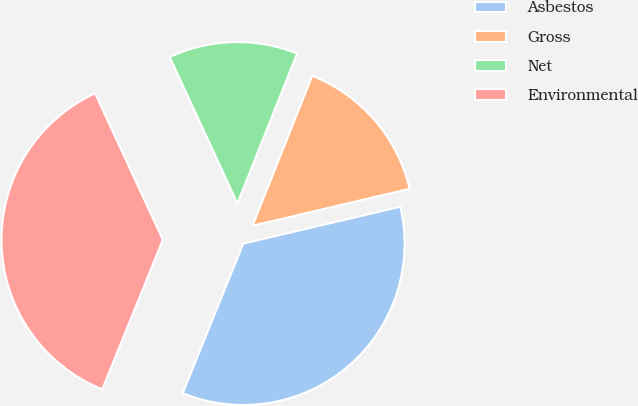Convert chart to OTSL. <chart><loc_0><loc_0><loc_500><loc_500><pie_chart><fcel>Asbestos<fcel>Gross<fcel>Net<fcel>Environmental<nl><fcel>34.8%<fcel>15.3%<fcel>12.92%<fcel>36.98%<nl></chart> 